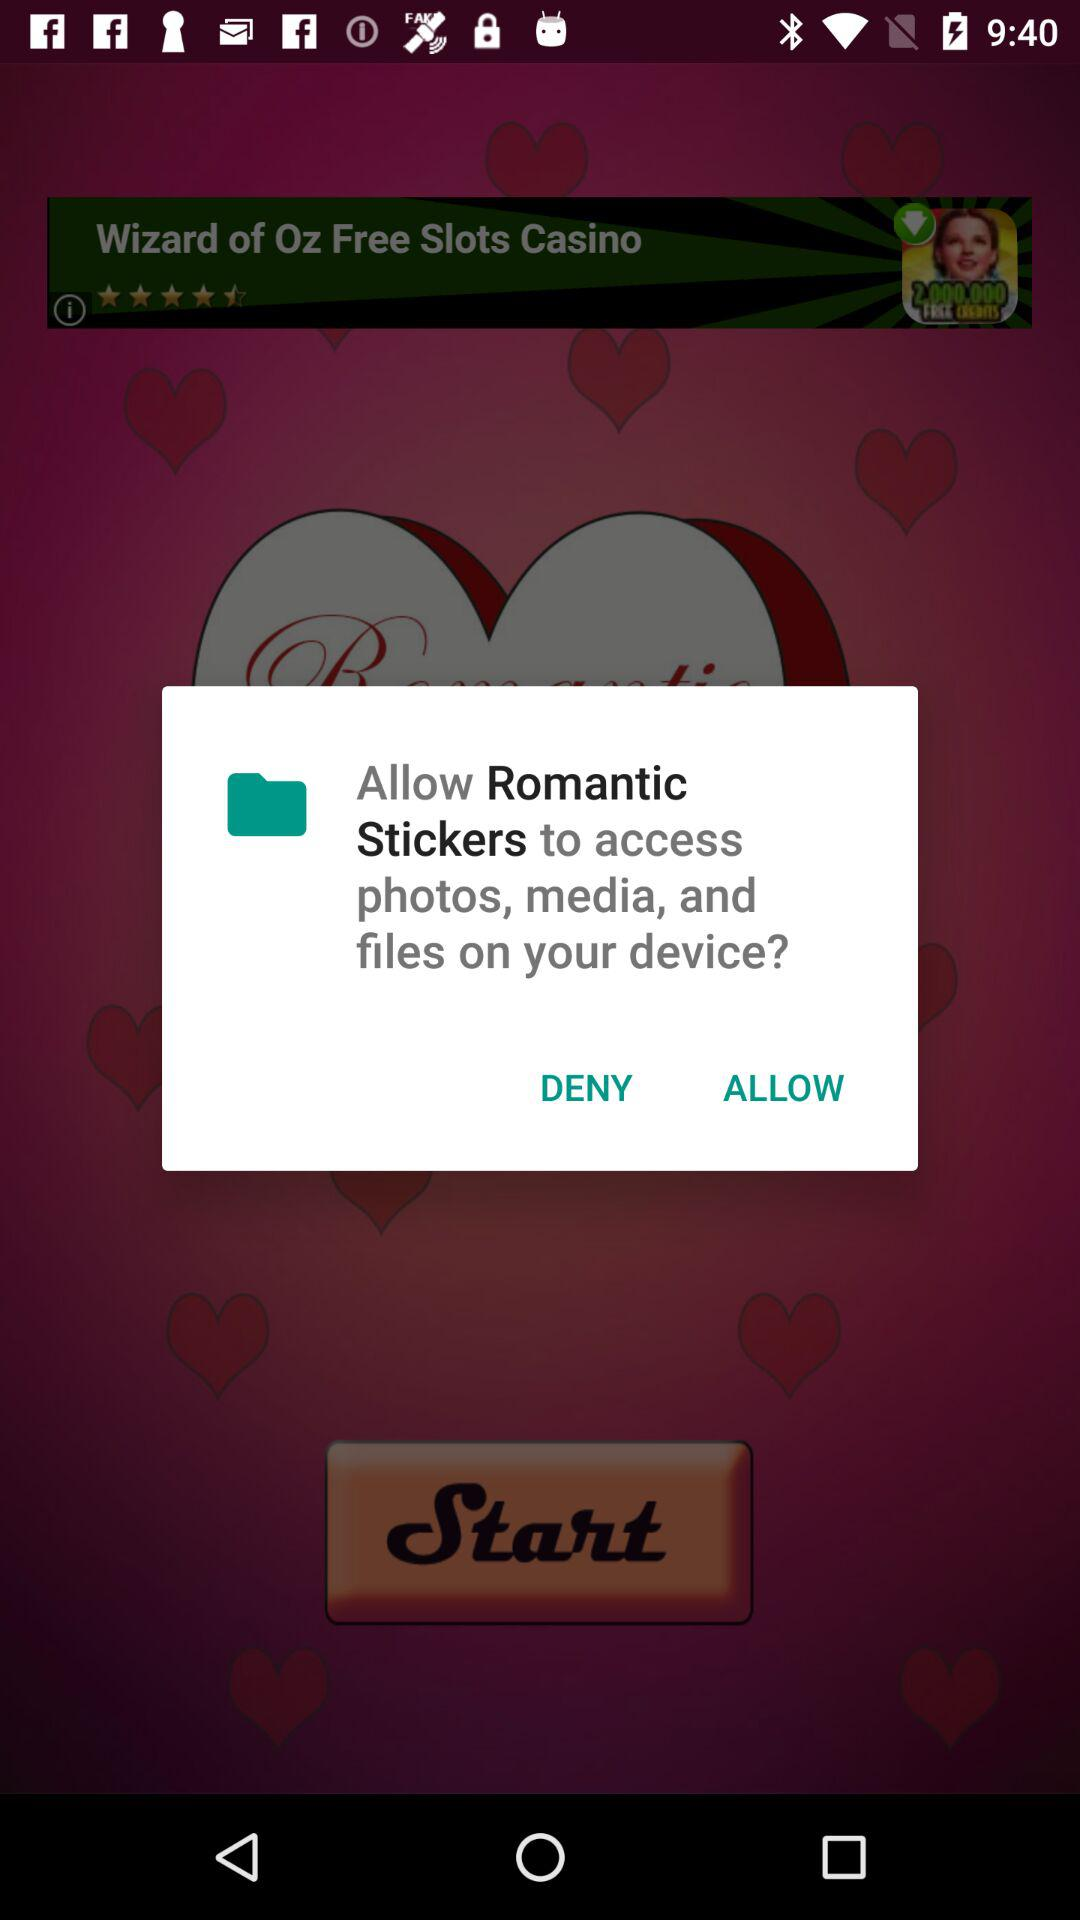What application needs access to photos, media, and files on the device? The application asking for permission is "Romantic Stickers". 